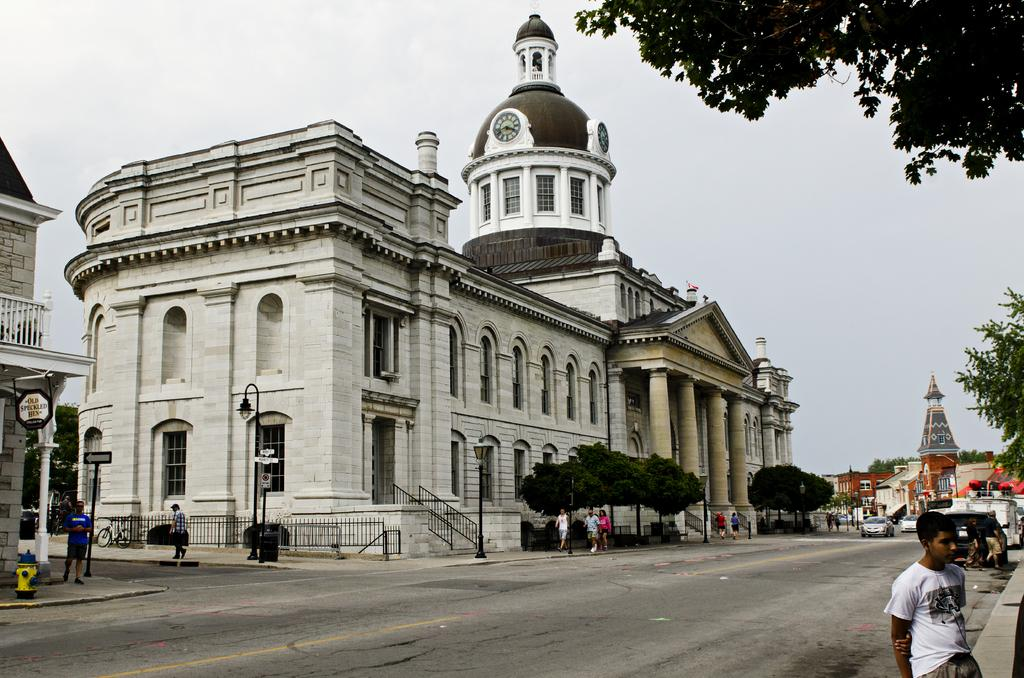What are the people in the image doing? There is a group of people standing on the road. What else can be seen on the path in the image? Several vehicles are parked on the path. What can be seen in the background of the image? There are group of buildings, trees, poles, and the sky visible in the background. What type of chalk is being used by the people in the image? There is no chalk present in the image; the people are standing on the road and there are parked vehicles on the path. 